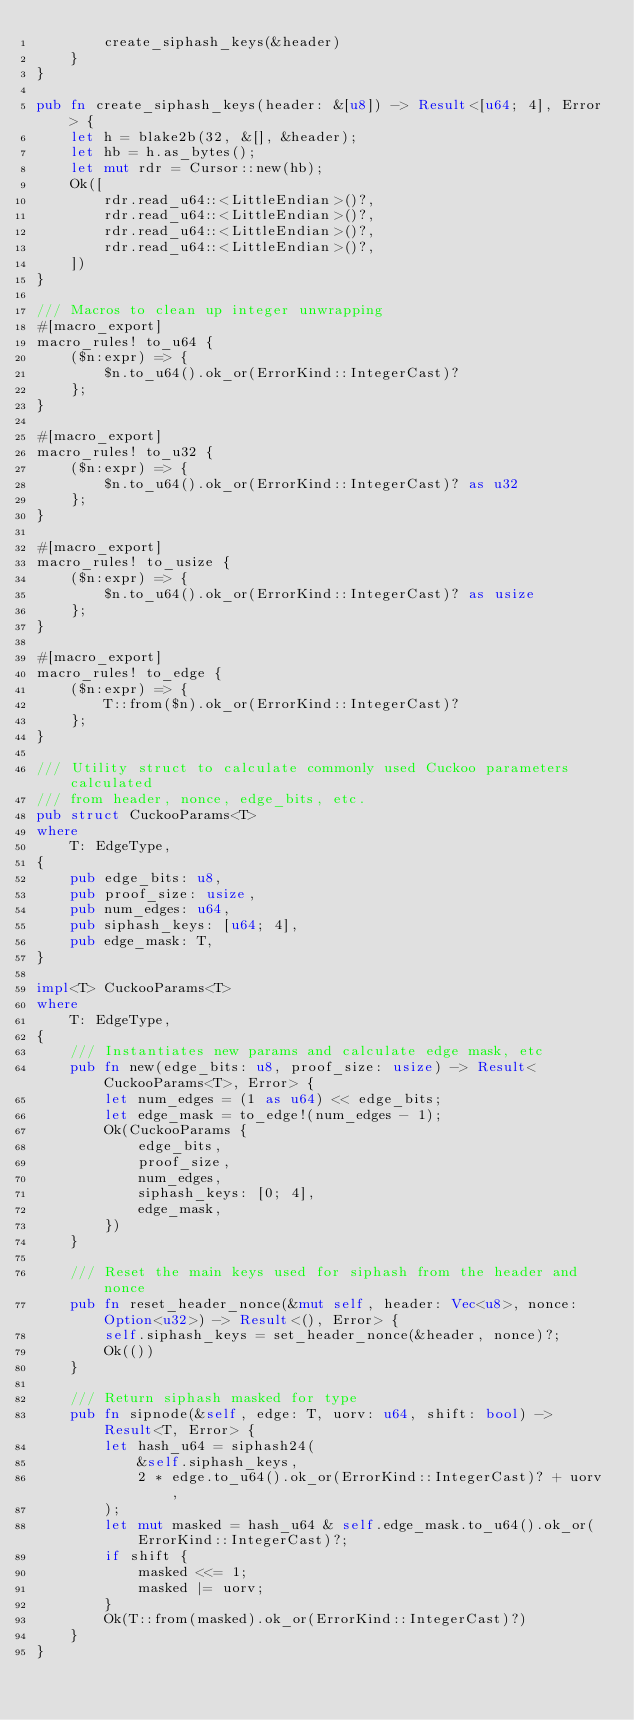Convert code to text. <code><loc_0><loc_0><loc_500><loc_500><_Rust_>		create_siphash_keys(&header)
	}
}

pub fn create_siphash_keys(header: &[u8]) -> Result<[u64; 4], Error> {
	let h = blake2b(32, &[], &header);
	let hb = h.as_bytes();
	let mut rdr = Cursor::new(hb);
	Ok([
		rdr.read_u64::<LittleEndian>()?,
		rdr.read_u64::<LittleEndian>()?,
		rdr.read_u64::<LittleEndian>()?,
		rdr.read_u64::<LittleEndian>()?,
	])
}

/// Macros to clean up integer unwrapping
#[macro_export]
macro_rules! to_u64 {
	($n:expr) => {
		$n.to_u64().ok_or(ErrorKind::IntegerCast)?
	};
}

#[macro_export]
macro_rules! to_u32 {
	($n:expr) => {
		$n.to_u64().ok_or(ErrorKind::IntegerCast)? as u32
	};
}

#[macro_export]
macro_rules! to_usize {
	($n:expr) => {
		$n.to_u64().ok_or(ErrorKind::IntegerCast)? as usize
	};
}

#[macro_export]
macro_rules! to_edge {
	($n:expr) => {
		T::from($n).ok_or(ErrorKind::IntegerCast)?
	};
}

/// Utility struct to calculate commonly used Cuckoo parameters calculated
/// from header, nonce, edge_bits, etc.
pub struct CuckooParams<T>
where
	T: EdgeType,
{
	pub edge_bits: u8,
	pub proof_size: usize,
	pub num_edges: u64,
	pub siphash_keys: [u64; 4],
	pub edge_mask: T,
}

impl<T> CuckooParams<T>
where
	T: EdgeType,
{
	/// Instantiates new params and calculate edge mask, etc
	pub fn new(edge_bits: u8, proof_size: usize) -> Result<CuckooParams<T>, Error> {
		let num_edges = (1 as u64) << edge_bits;
		let edge_mask = to_edge!(num_edges - 1);
		Ok(CuckooParams {
			edge_bits,
			proof_size,
			num_edges,
			siphash_keys: [0; 4],
			edge_mask,
		})
	}

	/// Reset the main keys used for siphash from the header and nonce
	pub fn reset_header_nonce(&mut self, header: Vec<u8>, nonce: Option<u32>) -> Result<(), Error> {
		self.siphash_keys = set_header_nonce(&header, nonce)?;
		Ok(())
	}

	/// Return siphash masked for type
	pub fn sipnode(&self, edge: T, uorv: u64, shift: bool) -> Result<T, Error> {
		let hash_u64 = siphash24(
			&self.siphash_keys,
			2 * edge.to_u64().ok_or(ErrorKind::IntegerCast)? + uorv,
		);
		let mut masked = hash_u64 & self.edge_mask.to_u64().ok_or(ErrorKind::IntegerCast)?;
		if shift {
			masked <<= 1;
			masked |= uorv;
		}
		Ok(T::from(masked).ok_or(ErrorKind::IntegerCast)?)
	}
}
</code> 